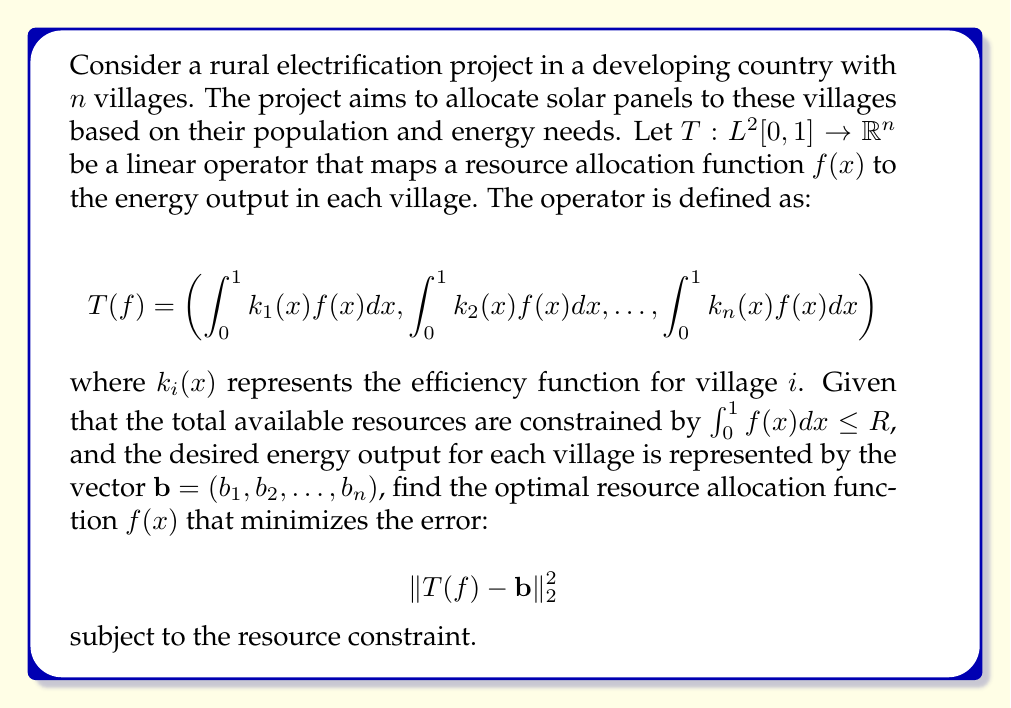What is the answer to this math problem? To solve this optimization problem, we can use the method of Lagrange multipliers and the theory of adjoint operators. Here's a step-by-step approach:

1) First, we formulate the Lagrangian:

   $$L(f, \lambda) = \|T(f) - \mathbf{b}\|_2^2 + \lambda(\int_0^1 f(x)dx - R)$$

2) The necessary condition for optimality is that the Fréchet derivative of $L$ with respect to $f$ equals zero:

   $$\frac{\partial L}{\partial f} = 2T^*(T(f) - \mathbf{b}) + \lambda = 0$$

   where $T^*$ is the adjoint operator of $T$.

3) The adjoint operator $T^*: \mathbb{R}^n \rightarrow L^2[0,1]$ is given by:

   $$(T^*\mathbf{y})(x) = \sum_{i=1}^n y_i k_i(x)$$

4) Substituting this into the optimality condition:

   $$2\sum_{i=1}^n (T(f)_i - b_i)k_i(x) + \lambda = 0$$

5) This implies that the optimal $f(x)$ has the form:

   $$f(x) = \sum_{i=1}^n \alpha_i k_i(x) - \frac{\lambda}{2}$$

   for some constants $\alpha_i$.

6) To find $\alpha_i$, we substitute this form back into the original equation:

   $$T(f)_j = \int_0^1 k_j(x)f(x)dx = \sum_{i=1}^n \alpha_i \int_0^1 k_i(x)k_j(x)dx - \frac{\lambda}{2}\int_0^1 k_j(x)dx$$

7) Let $K_{ij} = \int_0^1 k_i(x)k_j(x)dx$ and $v_j = \int_0^1 k_j(x)dx$. Then we have the system:

   $$K\mathbf{\alpha} - \frac{\lambda}{2}\mathbf{v} = \mathbf{b}$$

8) The resource constraint gives us an additional equation:

   $$\sum_{i=1}^n \alpha_i v_i - \frac{\lambda}{2} = R$$

9) Solving this system of $n+1$ equations will give us the values of $\alpha_i$ and $\lambda$, which completely determine the optimal $f(x)$.

The optimal $f(x)$ represents the best allocation of resources (solar panels) across the continuous domain [0,1], which can be interpreted as the geographical distribution of the resources.
Answer: The optimal resource allocation function is:

$$f(x) = \sum_{i=1}^n \alpha_i k_i(x) - \frac{\lambda}{2}$$

where $\alpha_i$ and $\lambda$ are obtained by solving the system:

$$\begin{cases}
K\mathbf{\alpha} - \frac{\lambda}{2}\mathbf{v} = \mathbf{b} \\
\sum_{i=1}^n \alpha_i v_i - \frac{\lambda}{2} = R
\end{cases}$$

with $K_{ij} = \int_0^1 k_i(x)k_j(x)dx$ and $v_j = \int_0^1 k_j(x)dx$. 